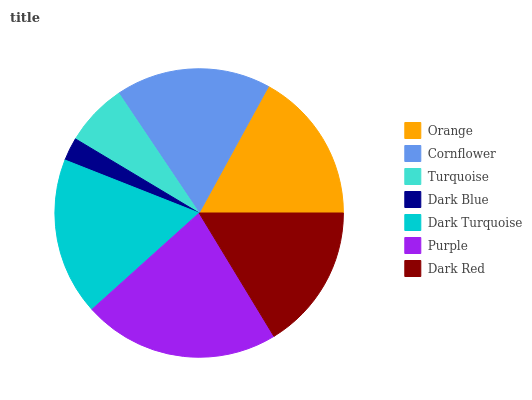Is Dark Blue the minimum?
Answer yes or no. Yes. Is Purple the maximum?
Answer yes or no. Yes. Is Cornflower the minimum?
Answer yes or no. No. Is Cornflower the maximum?
Answer yes or no. No. Is Cornflower greater than Orange?
Answer yes or no. Yes. Is Orange less than Cornflower?
Answer yes or no. Yes. Is Orange greater than Cornflower?
Answer yes or no. No. Is Cornflower less than Orange?
Answer yes or no. No. Is Orange the high median?
Answer yes or no. Yes. Is Orange the low median?
Answer yes or no. Yes. Is Dark Red the high median?
Answer yes or no. No. Is Dark Red the low median?
Answer yes or no. No. 